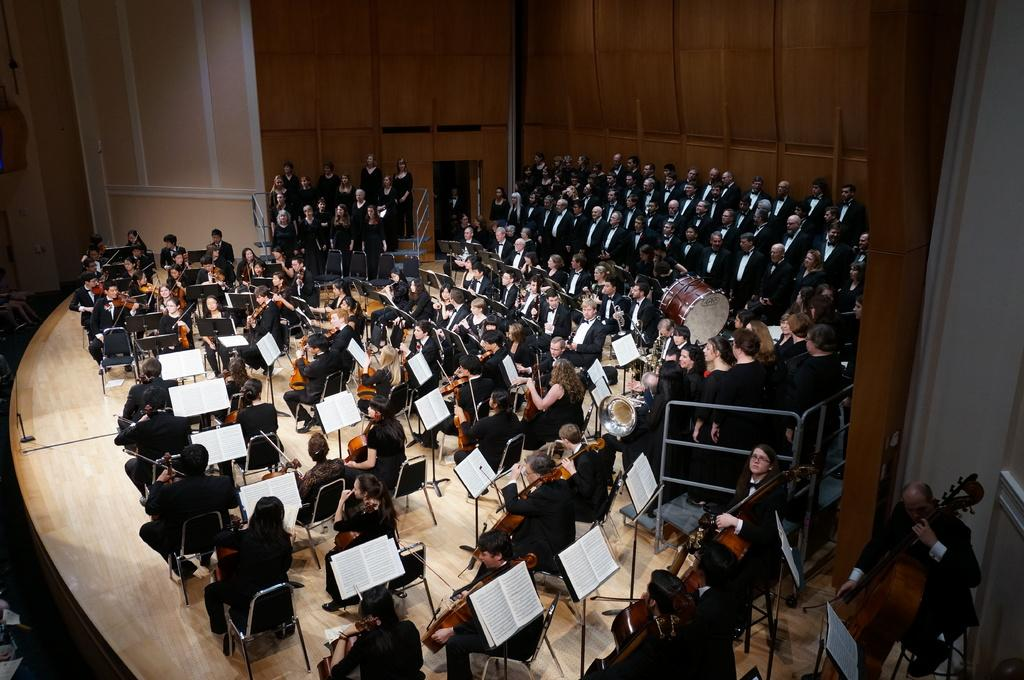How many people are in the image? There is a group of people in the people in the image. What are the people doing in the image? The people are sitting on chairs in the image. What objects can be seen in the image besides the people and chairs? There are books and guitars in the image. What is the background of the image? There is a wall in the image. What type of popcorn is being served in the image? There is no popcorn present in the image. How comfortable are the chairs in the image? The comfort level of the chairs cannot be determined from the image alone. 